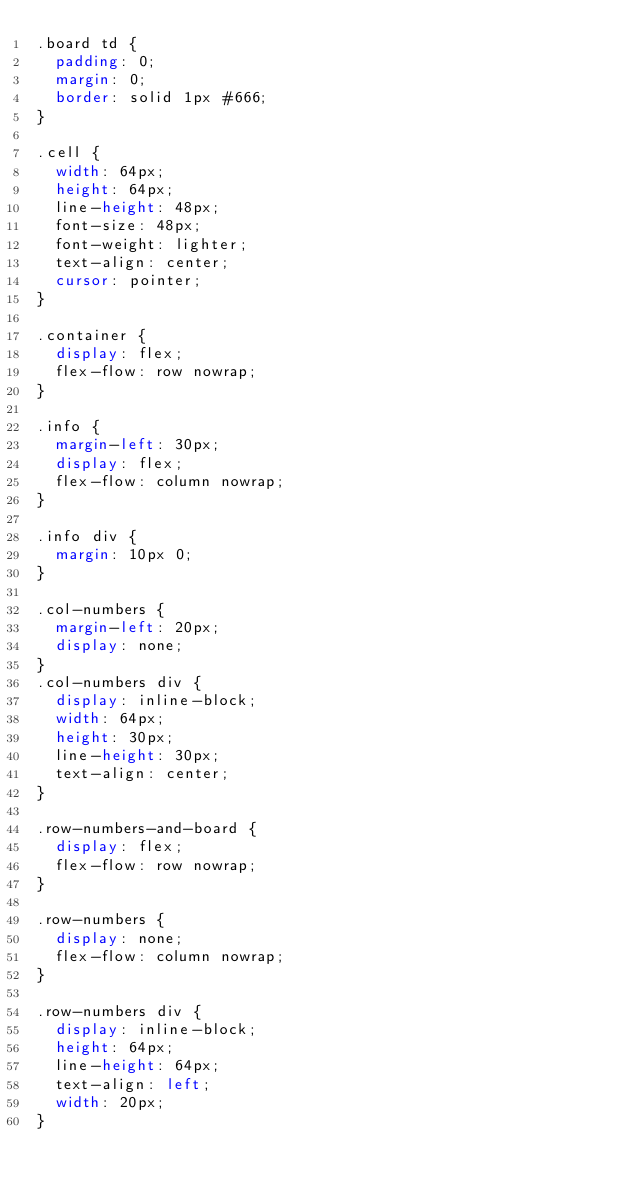Convert code to text. <code><loc_0><loc_0><loc_500><loc_500><_CSS_>.board td {
  padding: 0;
  margin: 0;
  border: solid 1px #666;
}

.cell {
  width: 64px;
  height: 64px;
  line-height: 48px;
  font-size: 48px;
  font-weight: lighter;
  text-align: center;
  cursor: pointer;
}

.container {
  display: flex;
  flex-flow: row nowrap;
}

.info {
  margin-left: 30px;
  display: flex;
  flex-flow: column nowrap;
}

.info div {
  margin: 10px 0;
}

.col-numbers {
  margin-left: 20px;
  display: none;
}
.col-numbers div {
  display: inline-block;
  width: 64px;
  height: 30px;
  line-height: 30px;
  text-align: center;
}

.row-numbers-and-board {
  display: flex;
  flex-flow: row nowrap;
}

.row-numbers {
  display: none;
  flex-flow: column nowrap;
}

.row-numbers div {
  display: inline-block;
  height: 64px;
  line-height: 64px;
  text-align: left;
  width: 20px;
}
</code> 